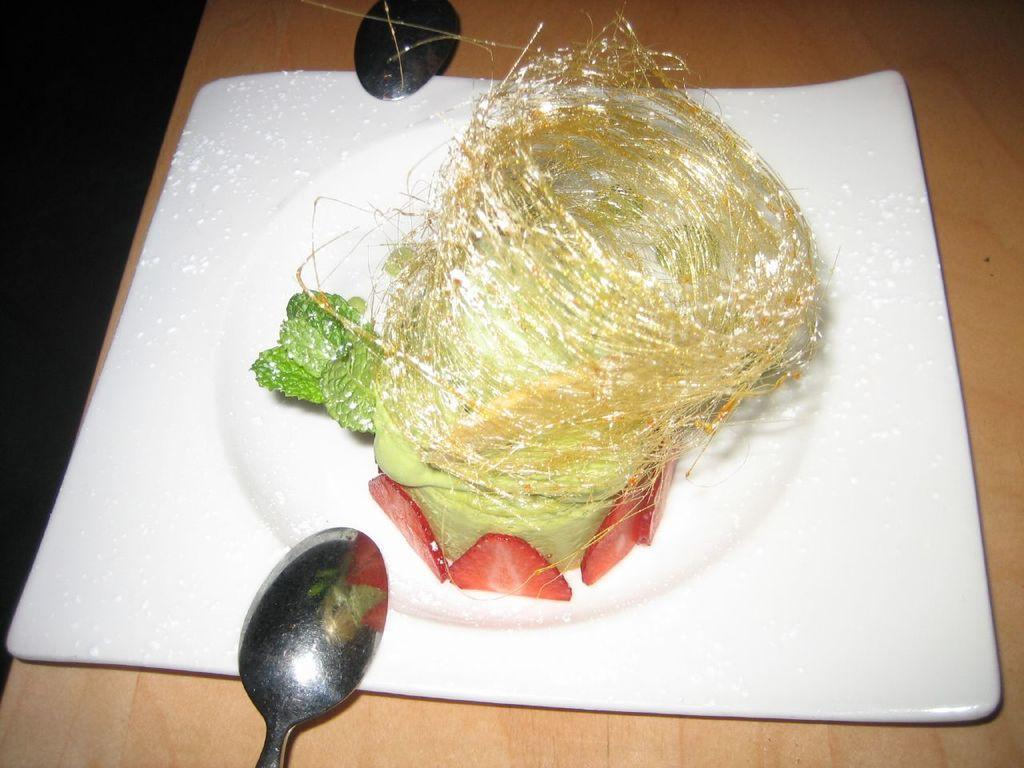What is on the plate that is visible in the image? There is a dessert in the plate. Where is the plate located in the image? The plate is placed on a table. What utensils are present in the image? There is a spoon on the top of the plate and another spoon at the bottom of the plate. What type of education is being taught in the image? There is no indication of any educational activity or subject in the image. 